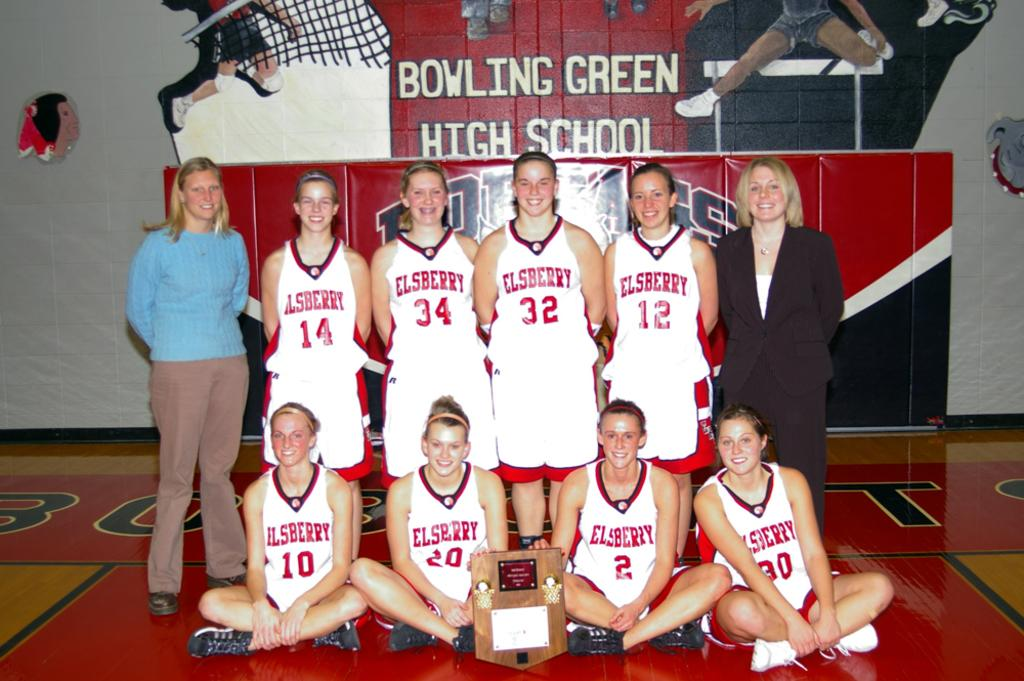<image>
Describe the image concisely. A group of basketball players are posting with a plaque and the wall behind them says Bowling Green High School. 